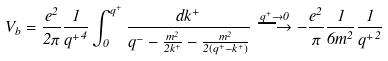<formula> <loc_0><loc_0><loc_500><loc_500>V _ { b } = \frac { e ^ { 2 } } { 2 \pi } \frac { 1 } { { q ^ { + } } ^ { 4 } } \int _ { 0 } ^ { q ^ { + } } \frac { d k ^ { + } } { q ^ { - } - \frac { m ^ { 2 } } { 2 k ^ { + } } - \frac { m ^ { 2 } } { 2 ( q ^ { + } - k ^ { + } ) } } \stackrel { q ^ { + } \rightarrow 0 } { \longrightarrow } - \frac { e ^ { 2 } } { \pi } \frac { 1 } { 6 m ^ { 2 } } \frac { 1 } { { q ^ { + } } ^ { 2 } }</formula> 